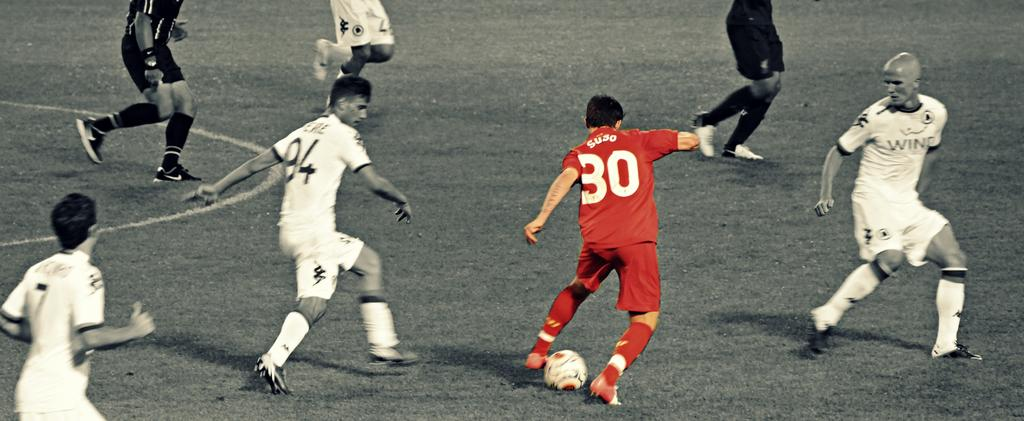<image>
Render a clear and concise summary of the photo. Player number 30 in red dribbles the soccer ball. 